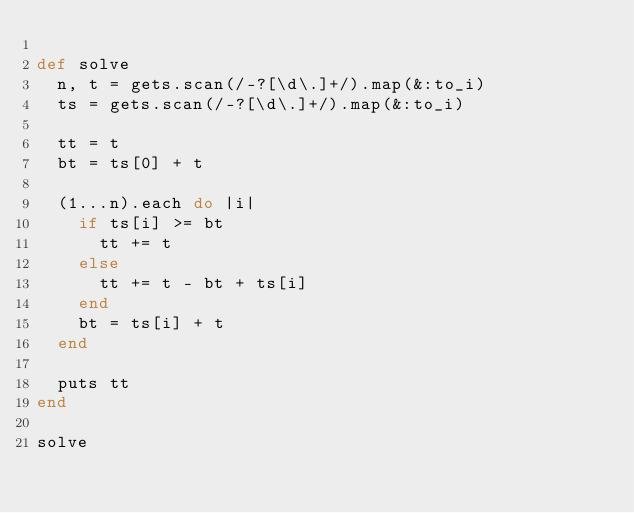<code> <loc_0><loc_0><loc_500><loc_500><_Ruby_>
def solve
  n, t = gets.scan(/-?[\d\.]+/).map(&:to_i)
  ts = gets.scan(/-?[\d\.]+/).map(&:to_i)

  tt = t
  bt = ts[0] + t

  (1...n).each do |i|
    if ts[i] >= bt
      tt += t
    else
      tt += t - bt + ts[i]
    end
    bt = ts[i] + t
  end

  puts tt
end

solve

</code> 